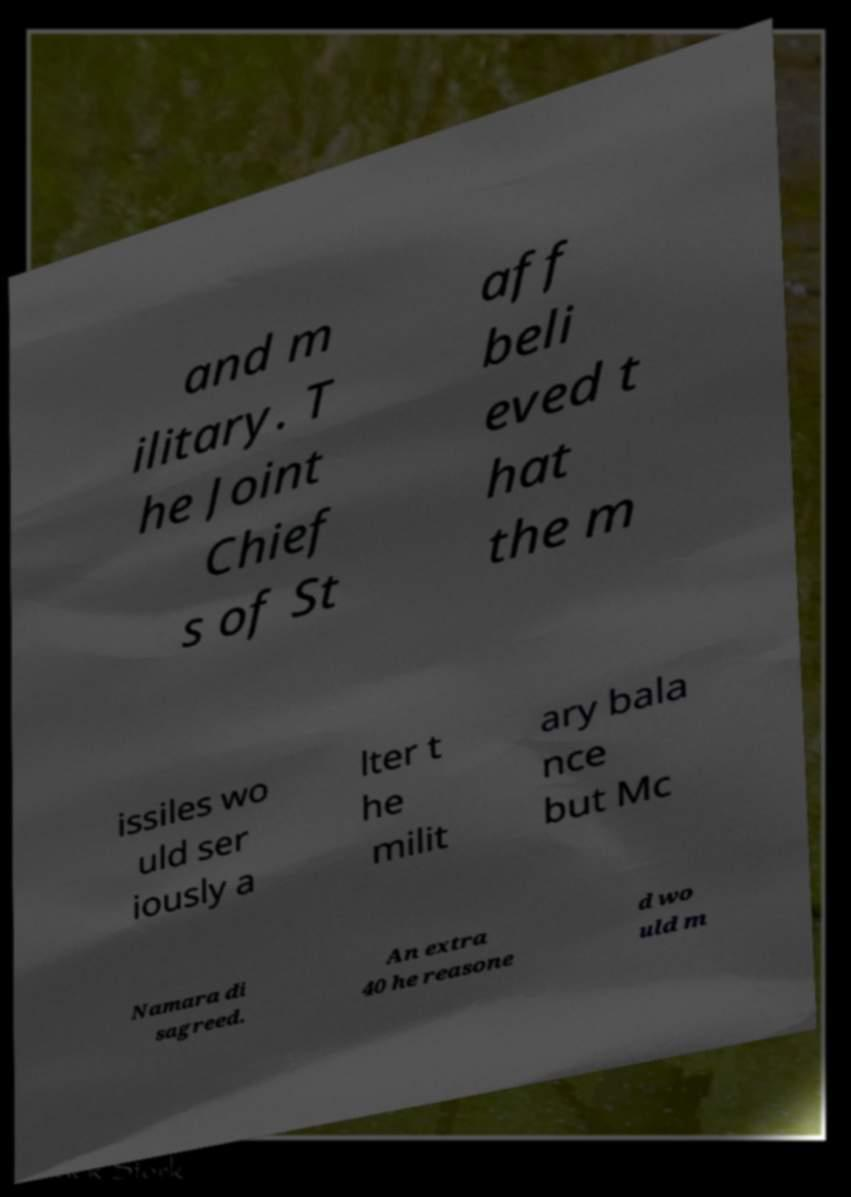Could you extract and type out the text from this image? and m ilitary. T he Joint Chief s of St aff beli eved t hat the m issiles wo uld ser iously a lter t he milit ary bala nce but Mc Namara di sagreed. An extra 40 he reasone d wo uld m 